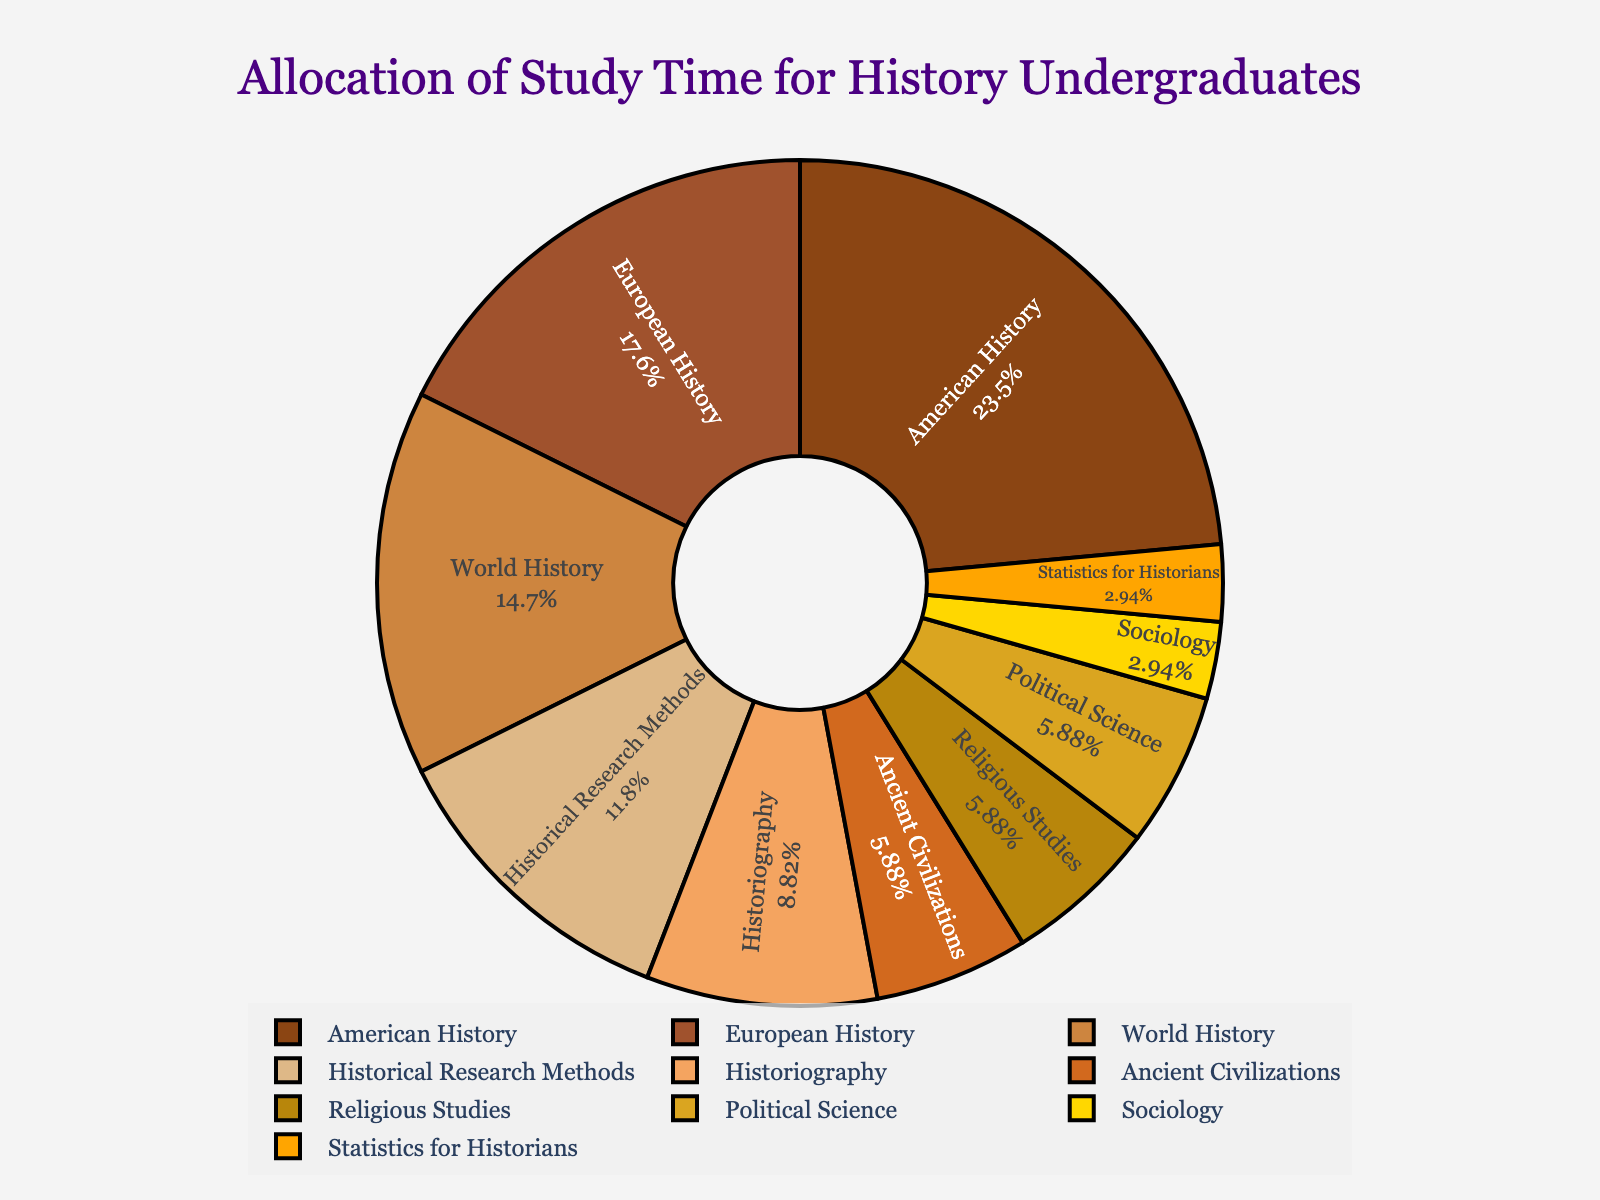What subject takes up the highest percentage of study time? American History takes up the highest percentage of study time. This can be identified by looking at the largest segment of the pie chart.
Answer: American History How many hours per week do students spend on European History and World History combined? European History and World History segments need to be summed up. European History accounts for 6 hours and World History accounts for 5 hours, so 6 + 5 = 11 hours.
Answer: 11 hours Which subjects each take up less than 5% of total study time? We need to identify segments that look visually smaller than 5%. Since the total hours are 34, 5% of 34 is 1.7 hours. Subjects with study time less than 1.7 hours are Statistics for Historians (1 hour) and Sociology (1 hour).
Answer: Statistics for Historians, Sociology What color represents the study time for Ancient Civilizations? By finding the segment labeled Ancient Civilizations in the pie chart, we can see that it is represented by a specific brown shade in the chart.
Answer: Brown How much more time do students spend on American History than on Historiography? First, find the hours for both subjects. American History is 8 hours and Historiography is 3 hours. The difference is 8 - 3 = 5 hours.
Answer: 5 hours Arrange the subjects in descending order of study time. Based on the segments' sizes, list subjects starting with the largest: American History (8), European History (6), World History (5), Historical Research Methods (4), Historiography (3), Ancient Civilizations (2), Religious Studies (2), Political Science (2), Statistics for Historians (1), Sociology (1).
Answer: American History, European History, World History, Historical Research Methods, Historiography, Ancient Civilizations, Religious Studies, Political Science, Statistics for Historians, Sociology What percentage of total study time is allocated to Political Science and Religious Studies combined? Political Science and Religious Studies segments need to be summed. Both have 2 hours each, totaling 4 hours. The percentage is calculated by (4/34) * 100 ≈ 11.8%.
Answer: 11.8% Which subject has a study time equal to half of the time spent on World History? World History is allocated 5 hours. Half would be 5/2 = 2.5 hours. Since no subject exactly matches this, we look for the closest value, which might not be directly present.
Answer: None 